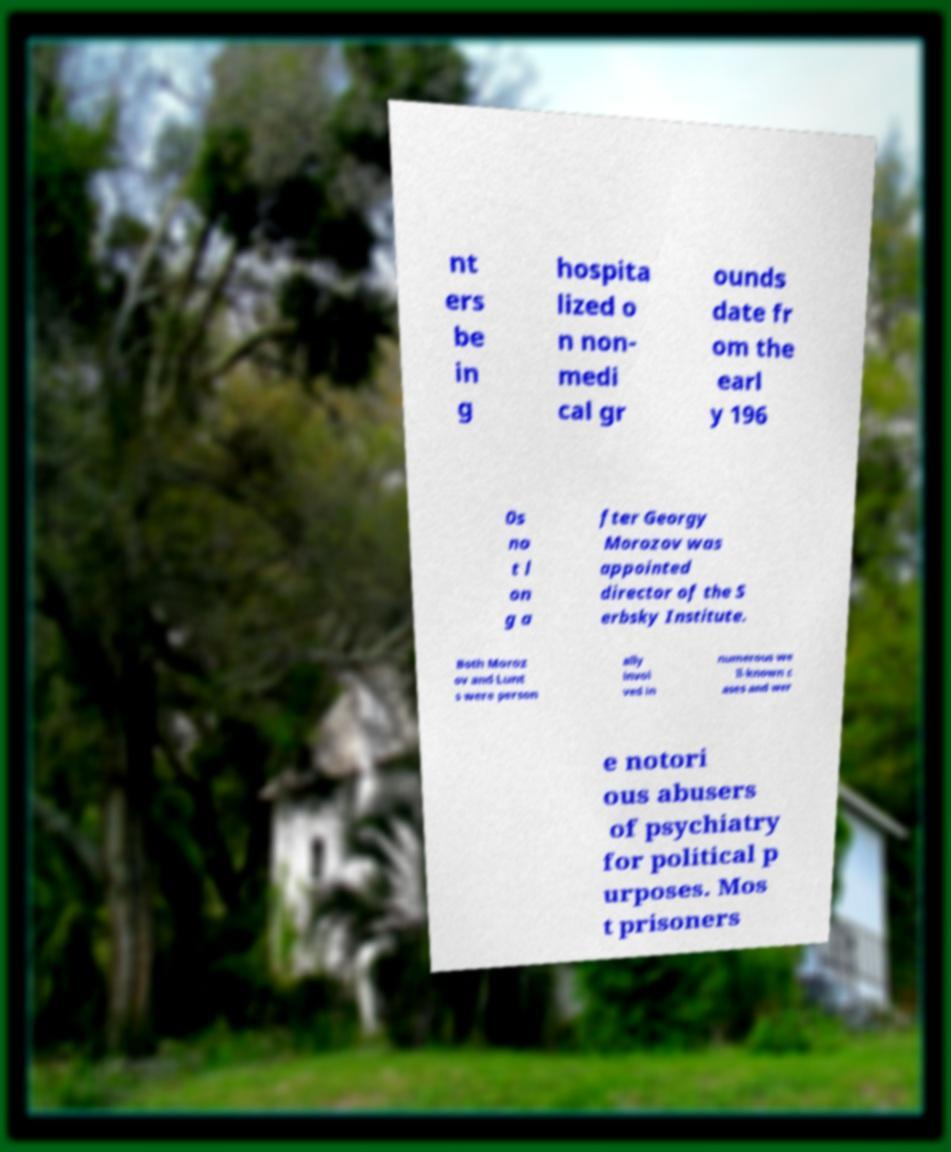Please read and relay the text visible in this image. What does it say? nt ers be in g hospita lized o n non- medi cal gr ounds date fr om the earl y 196 0s no t l on g a fter Georgy Morozov was appointed director of the S erbsky Institute. Both Moroz ov and Lunt s were person ally invol ved in numerous we ll-known c ases and wer e notori ous abusers of psychiatry for political p urposes. Mos t prisoners 